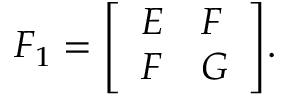<formula> <loc_0><loc_0><loc_500><loc_500>F _ { 1 } = { \left [ \begin{array} { l l } { E } & { F } \\ { F } & { G } \end{array} \right ] } .</formula> 